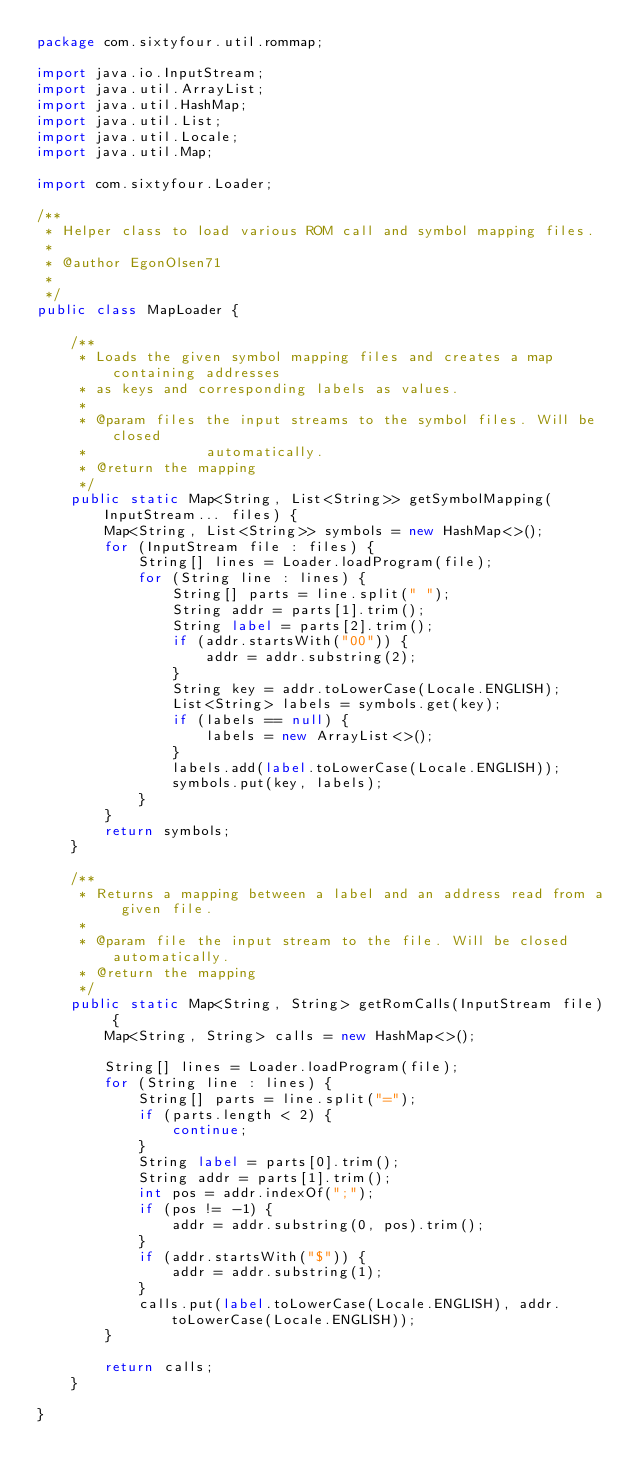Convert code to text. <code><loc_0><loc_0><loc_500><loc_500><_Java_>package com.sixtyfour.util.rommap;

import java.io.InputStream;
import java.util.ArrayList;
import java.util.HashMap;
import java.util.List;
import java.util.Locale;
import java.util.Map;

import com.sixtyfour.Loader;

/**
 * Helper class to load various ROM call and symbol mapping files.
 * 
 * @author EgonOlsen71
 *
 */
public class MapLoader {

	/**
	 * Loads the given symbol mapping files and creates a map containing addresses
	 * as keys and corresponding labels as values.
	 * 
	 * @param files the input streams to the symbol files. Will be closed
	 *              automatically.
	 * @return the mapping
	 */
	public static Map<String, List<String>> getSymbolMapping(InputStream... files) {
		Map<String, List<String>> symbols = new HashMap<>();
		for (InputStream file : files) {
			String[] lines = Loader.loadProgram(file);
			for (String line : lines) {
				String[] parts = line.split(" ");
				String addr = parts[1].trim();
				String label = parts[2].trim();
				if (addr.startsWith("00")) {
					addr = addr.substring(2);
				}
				String key = addr.toLowerCase(Locale.ENGLISH);
				List<String> labels = symbols.get(key);
				if (labels == null) {
					labels = new ArrayList<>();
				}
				labels.add(label.toLowerCase(Locale.ENGLISH));
				symbols.put(key, labels);
			}
		}
		return symbols;
	}

	/**
	 * Returns a mapping between a label and an address read from a given file.
	 * 
	 * @param file the input stream to the file. Will be closed automatically.
	 * @return the mapping
	 */
	public static Map<String, String> getRomCalls(InputStream file) {
		Map<String, String> calls = new HashMap<>();

		String[] lines = Loader.loadProgram(file);
		for (String line : lines) {
			String[] parts = line.split("=");
			if (parts.length < 2) {
				continue;
			}
			String label = parts[0].trim();
			String addr = parts[1].trim();
			int pos = addr.indexOf(";");
			if (pos != -1) {
				addr = addr.substring(0, pos).trim();
			}
			if (addr.startsWith("$")) {
				addr = addr.substring(1);
			}
			calls.put(label.toLowerCase(Locale.ENGLISH), addr.toLowerCase(Locale.ENGLISH));
		}

		return calls;
	}

}
</code> 